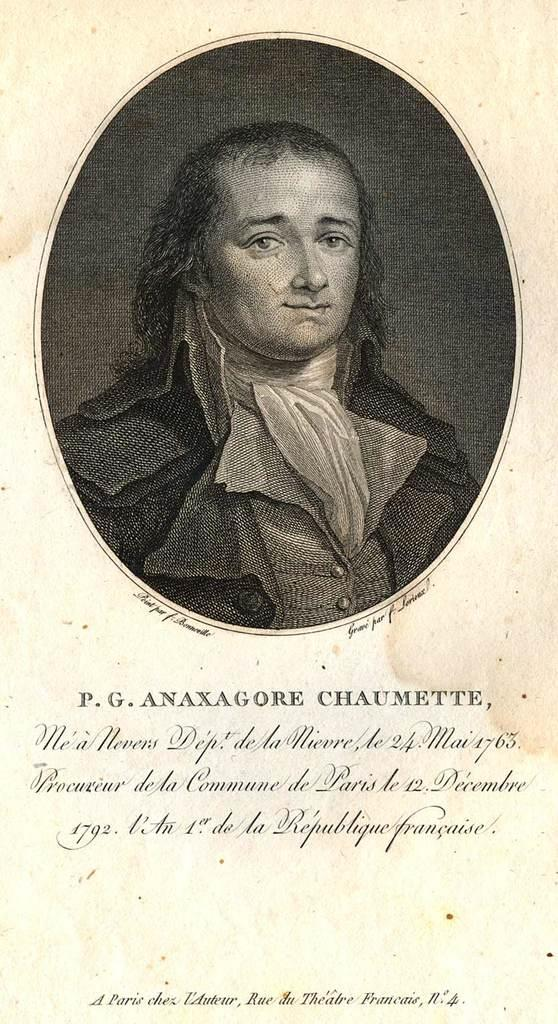What is the main subject of the image? There is a depiction of a person in the image. Are there any words or letters in the image? Yes, there is some text in the image. How many ants can be seen carrying sticks in the image? There are no ants or sticks present in the image. What type of trucks are visible in the image? There are no trucks visible in the image. 